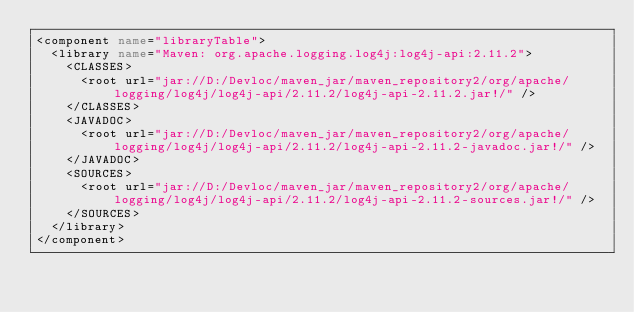<code> <loc_0><loc_0><loc_500><loc_500><_XML_><component name="libraryTable">
  <library name="Maven: org.apache.logging.log4j:log4j-api:2.11.2">
    <CLASSES>
      <root url="jar://D:/Devloc/maven_jar/maven_repository2/org/apache/logging/log4j/log4j-api/2.11.2/log4j-api-2.11.2.jar!/" />
    </CLASSES>
    <JAVADOC>
      <root url="jar://D:/Devloc/maven_jar/maven_repository2/org/apache/logging/log4j/log4j-api/2.11.2/log4j-api-2.11.2-javadoc.jar!/" />
    </JAVADOC>
    <SOURCES>
      <root url="jar://D:/Devloc/maven_jar/maven_repository2/org/apache/logging/log4j/log4j-api/2.11.2/log4j-api-2.11.2-sources.jar!/" />
    </SOURCES>
  </library>
</component></code> 